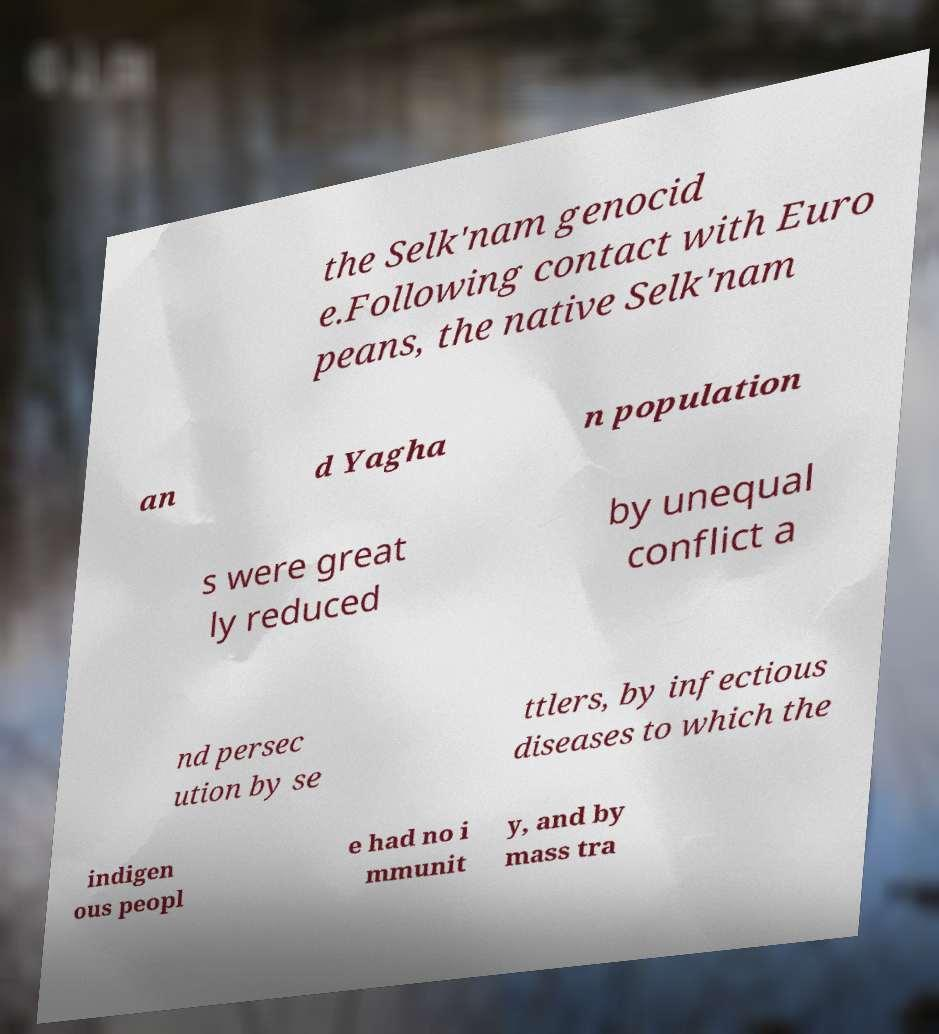Could you assist in decoding the text presented in this image and type it out clearly? the Selk'nam genocid e.Following contact with Euro peans, the native Selk'nam an d Yagha n population s were great ly reduced by unequal conflict a nd persec ution by se ttlers, by infectious diseases to which the indigen ous peopl e had no i mmunit y, and by mass tra 